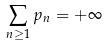Convert formula to latex. <formula><loc_0><loc_0><loc_500><loc_500>\sum _ { n \geq 1 } p _ { n } = + \infty \,</formula> 